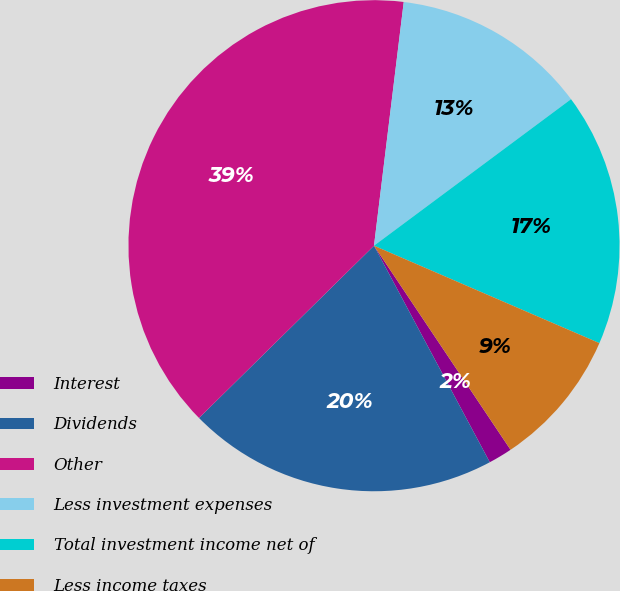<chart> <loc_0><loc_0><loc_500><loc_500><pie_chart><fcel>Interest<fcel>Dividends<fcel>Other<fcel>Less investment expenses<fcel>Total investment income net of<fcel>Less income taxes<nl><fcel>1.57%<fcel>20.44%<fcel>39.31%<fcel>12.89%<fcel>16.67%<fcel>9.12%<nl></chart> 